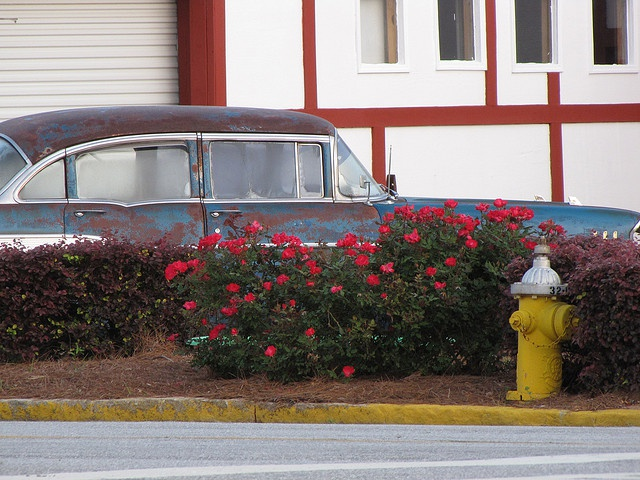Describe the objects in this image and their specific colors. I can see car in lightgray, gray, and darkgray tones and fire hydrant in lightgray, olive, and darkgray tones in this image. 